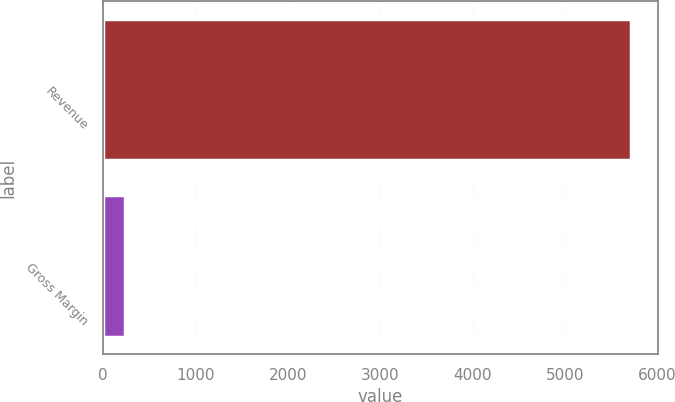Convert chart to OTSL. <chart><loc_0><loc_0><loc_500><loc_500><bar_chart><fcel>Revenue<fcel>Gross Margin<nl><fcel>5720<fcel>234<nl></chart> 